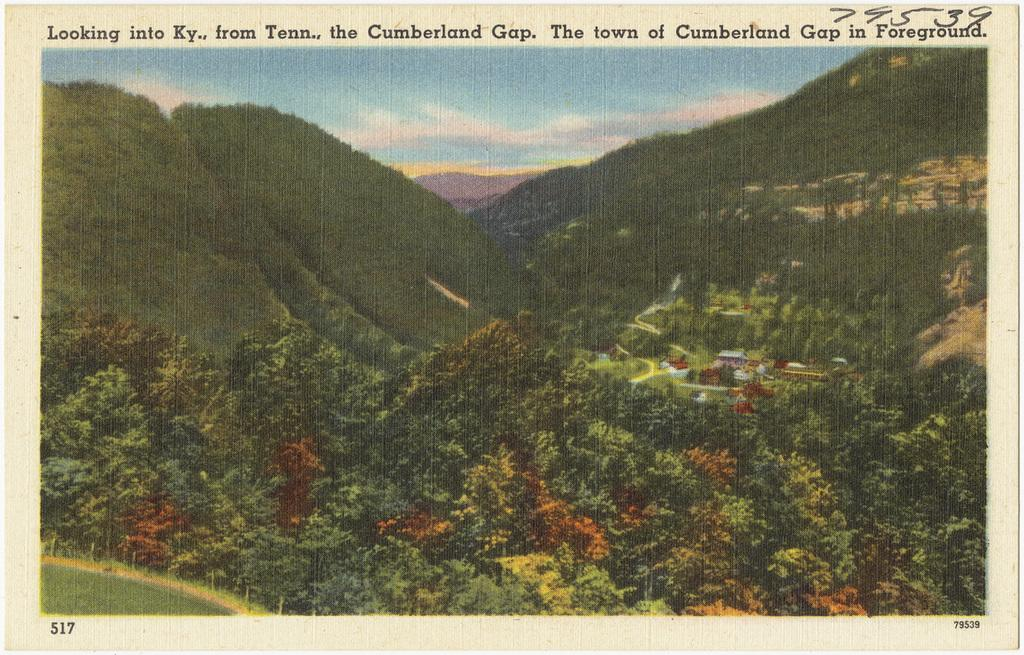What is featured on the poster in the image? The facts provided do not specify what is on the poster. What type of vegetation can be seen in the image? There are groups of trees in the image. What can be seen in the sky in the image? There are clouds in the sky. Is there a hill visible in the image? There is no mention of a hill in the provided facts, so it cannot be determined if one is present in the image. 